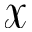<formula> <loc_0><loc_0><loc_500><loc_500>\mathbf c a l { X }</formula> 